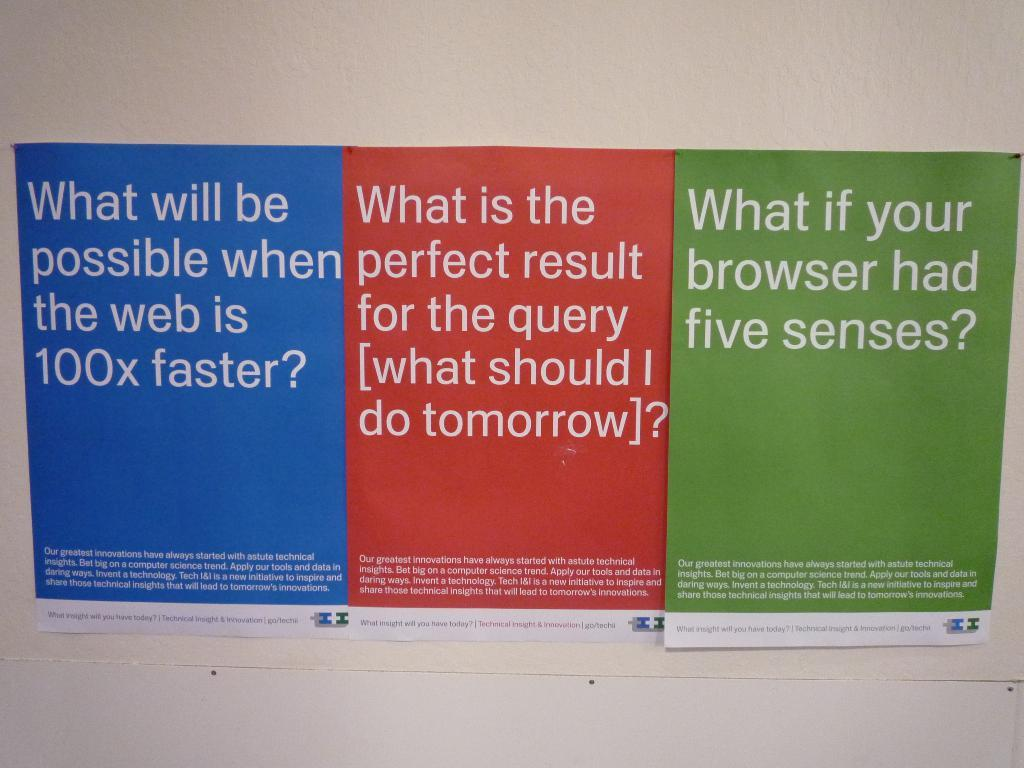<image>
Offer a succinct explanation of the picture presented. A sign asks the question, what if your browser had five senses. 